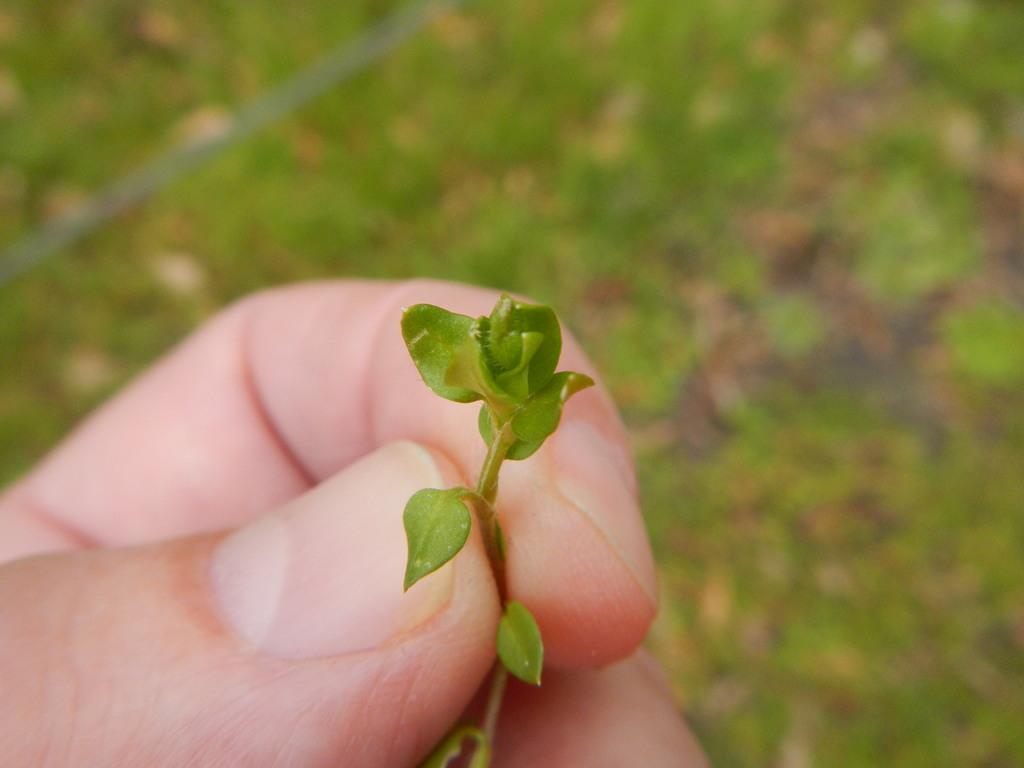What is being held by the hand in the image? The hand is holding a flower. Can you describe the background of the image? The image appears to depict a grassy land in the background. What type of mint can be seen growing among the cattle in the image? There is no mint or cattle present in the image; it only features a hand holding a flower and a grassy background. 